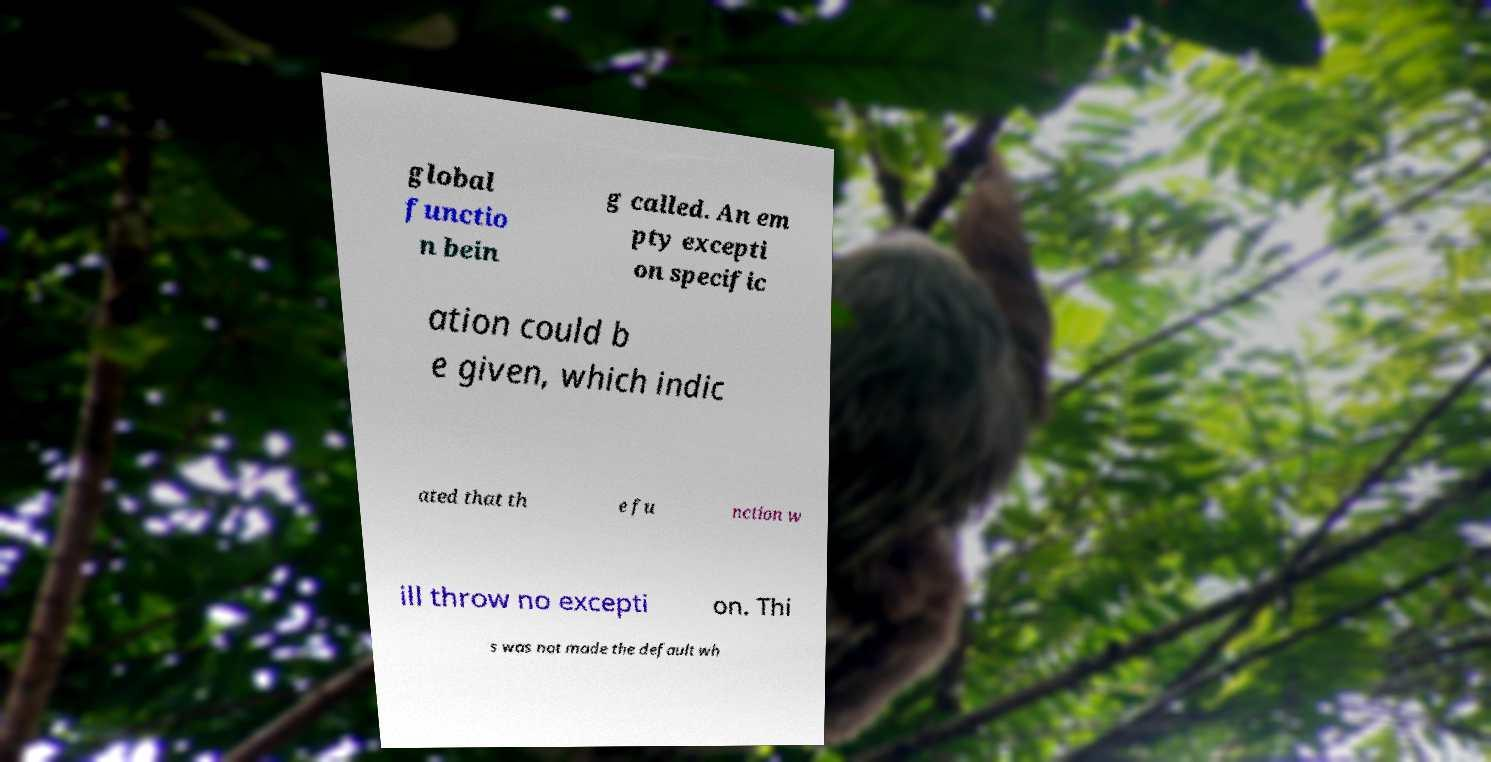There's text embedded in this image that I need extracted. Can you transcribe it verbatim? global functio n bein g called. An em pty excepti on specific ation could b e given, which indic ated that th e fu nction w ill throw no excepti on. Thi s was not made the default wh 